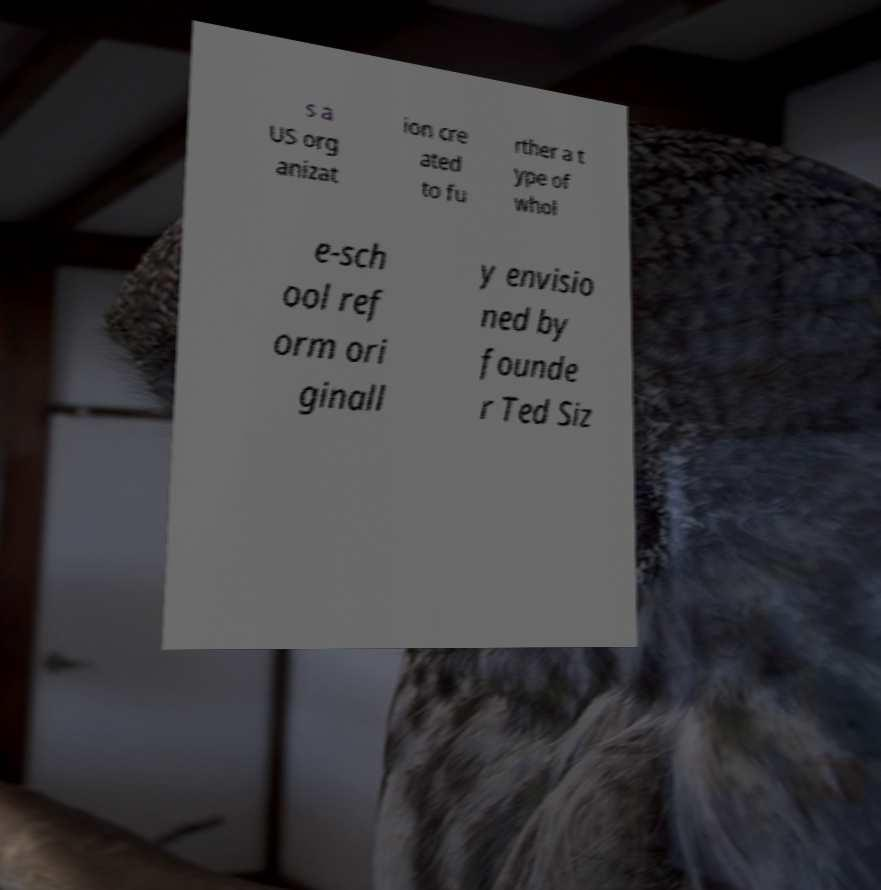Can you accurately transcribe the text from the provided image for me? s a US org anizat ion cre ated to fu rther a t ype of whol e-sch ool ref orm ori ginall y envisio ned by founde r Ted Siz 